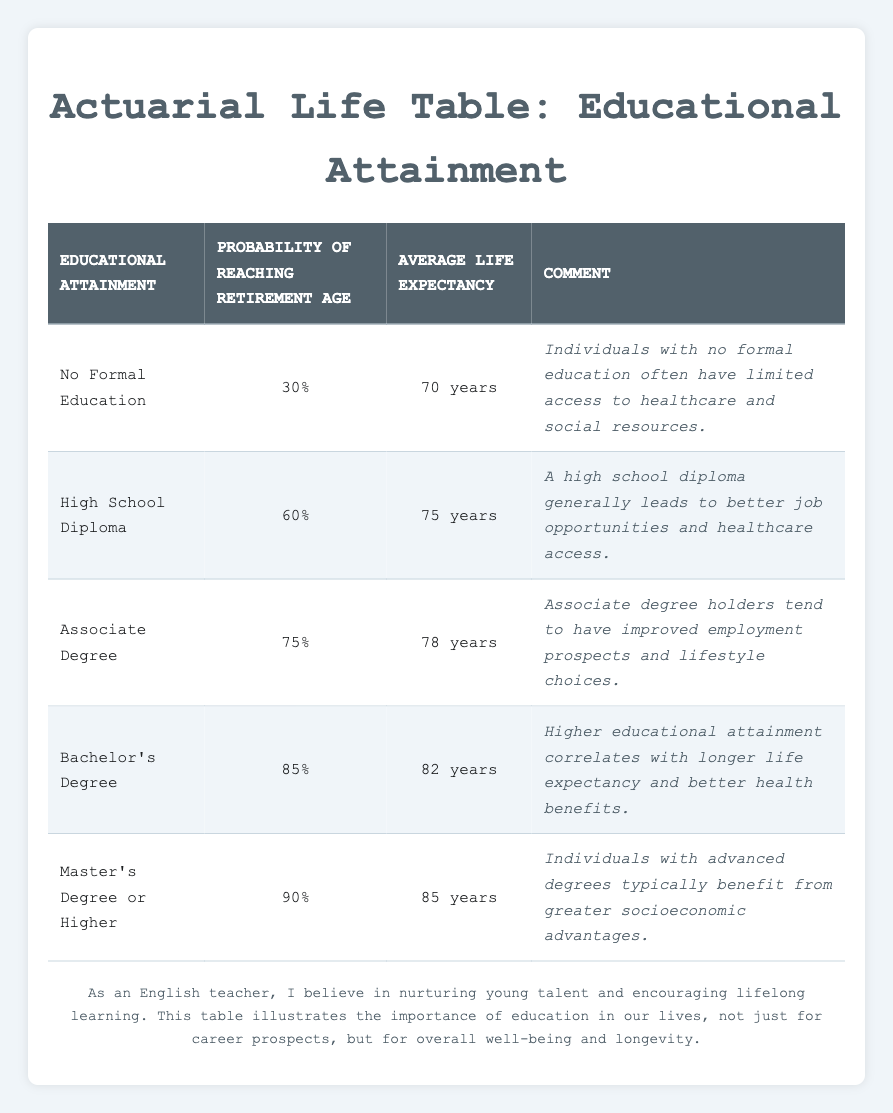What is the probability of a person with a Bachelor's Degree reaching retirement age? From the table, the probability for a Bachelor's Degree is listed as 85%.
Answer: 85% What is the average life expectancy for individuals with a Master's Degree or Higher? According to the table, the average life expectancy for this educational level is 85 years.
Answer: 85 years True or False: Individuals with no formal education have a higher probability of reaching retirement age than those with a High School Diploma. The probability for those with no formal education is 30%, while for those with a High School Diploma, it is 60%. Therefore, the statement is false.
Answer: False What is the difference in the probability of reaching retirement age between individuals with an Associate Degree and those with a High School Diploma? The probability for an Associate Degree is 75%, and for a High School Diploma it is 60%. The difference is 75% - 60% = 15%.
Answer: 15% If you combine the average life expectancy of someone with no formal education and a high school diploma, what is the total? The average life expectancy for no formal education is 70 years, and for a high school diploma, it is 75 years. The total is 70 + 75 = 145 years.
Answer: 145 years What percentage of those with a Master’s Degree or higher are expected to reach retirement age? The table states that 90% of individuals with a Master's Degree or higher are expected to reach retirement age.
Answer: 90% Which educational attainment level has the lowest probability of reaching retirement age? By checking the table, it shows that "No Formal Education" has the lowest probability at 30%.
Answer: No Formal Education What is the average life expectancy of individuals with a Bachelor's Degree compared to those with an Associate Degree? The table indicates that the average life expectancy for a Bachelor's Degree is 82 years and for an Associate Degree is 78 years. Thus, the Bachelor's Degree has a higher expectancy.
Answer: Bachelor's Degree has 82 years How likely is it that an individual with only a high school diploma will reach retirement age compared to one with a Master's Degree or higher? The odds are 60% for a high school diploma and 90% for a Master's Degree or higher. This indicates a 30% higher probability for those with a Master's Degree.
Answer: 30% higher probability for Master's Degree 